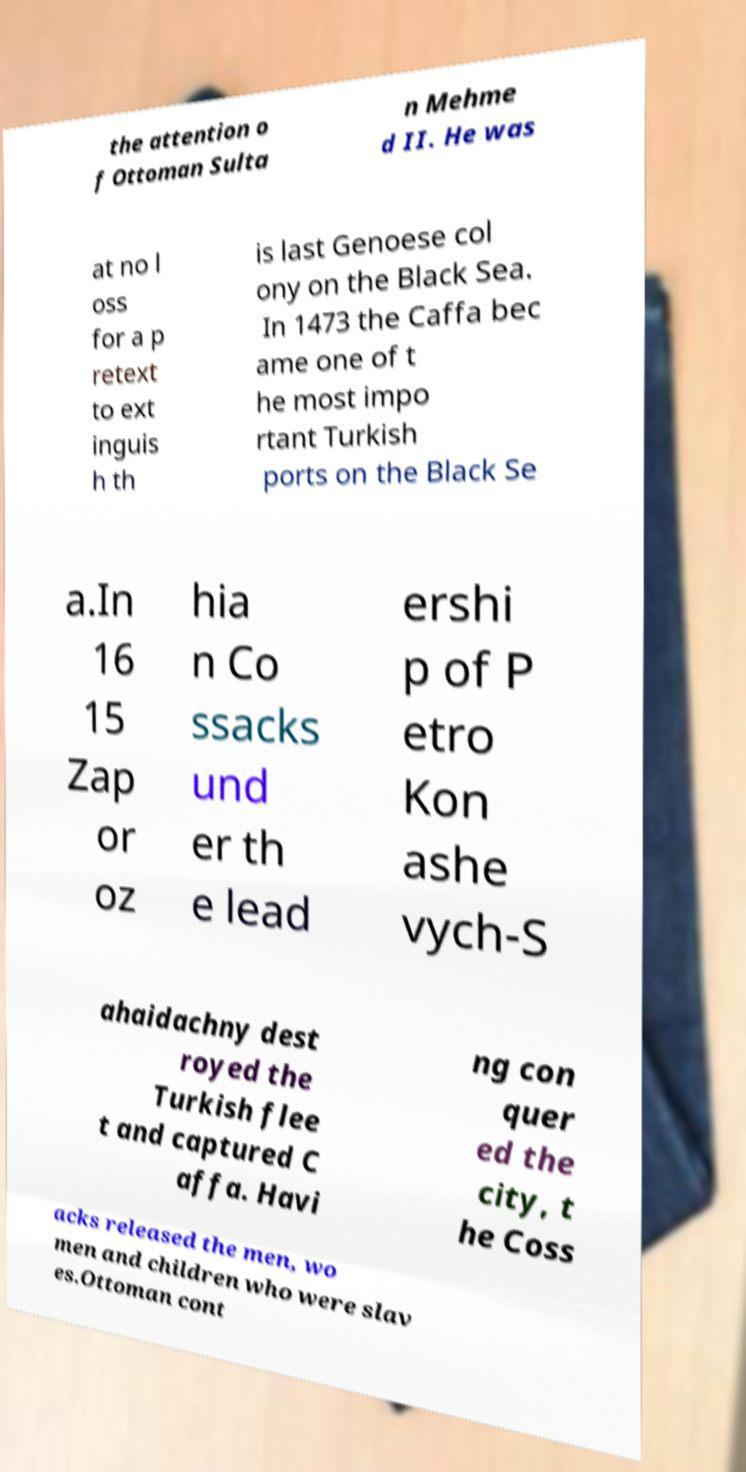Could you assist in decoding the text presented in this image and type it out clearly? the attention o f Ottoman Sulta n Mehme d II. He was at no l oss for a p retext to ext inguis h th is last Genoese col ony on the Black Sea. In 1473 the Caffa bec ame one of t he most impo rtant Turkish ports on the Black Se a.In 16 15 Zap or oz hia n Co ssacks und er th e lead ershi p of P etro Kon ashe vych-S ahaidachny dest royed the Turkish flee t and captured C affa. Havi ng con quer ed the city, t he Coss acks released the men, wo men and children who were slav es.Ottoman cont 